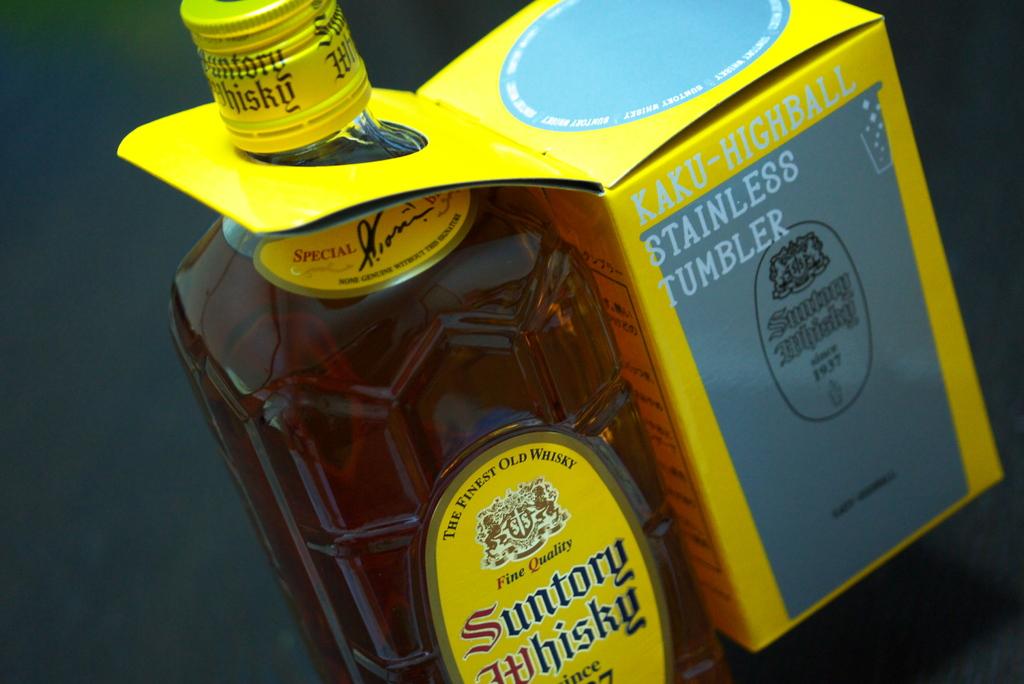What is written on the box?
Provide a succinct answer. Stainless tumbler. What kind of whisky is this?
Your answer should be very brief. Suntory. 